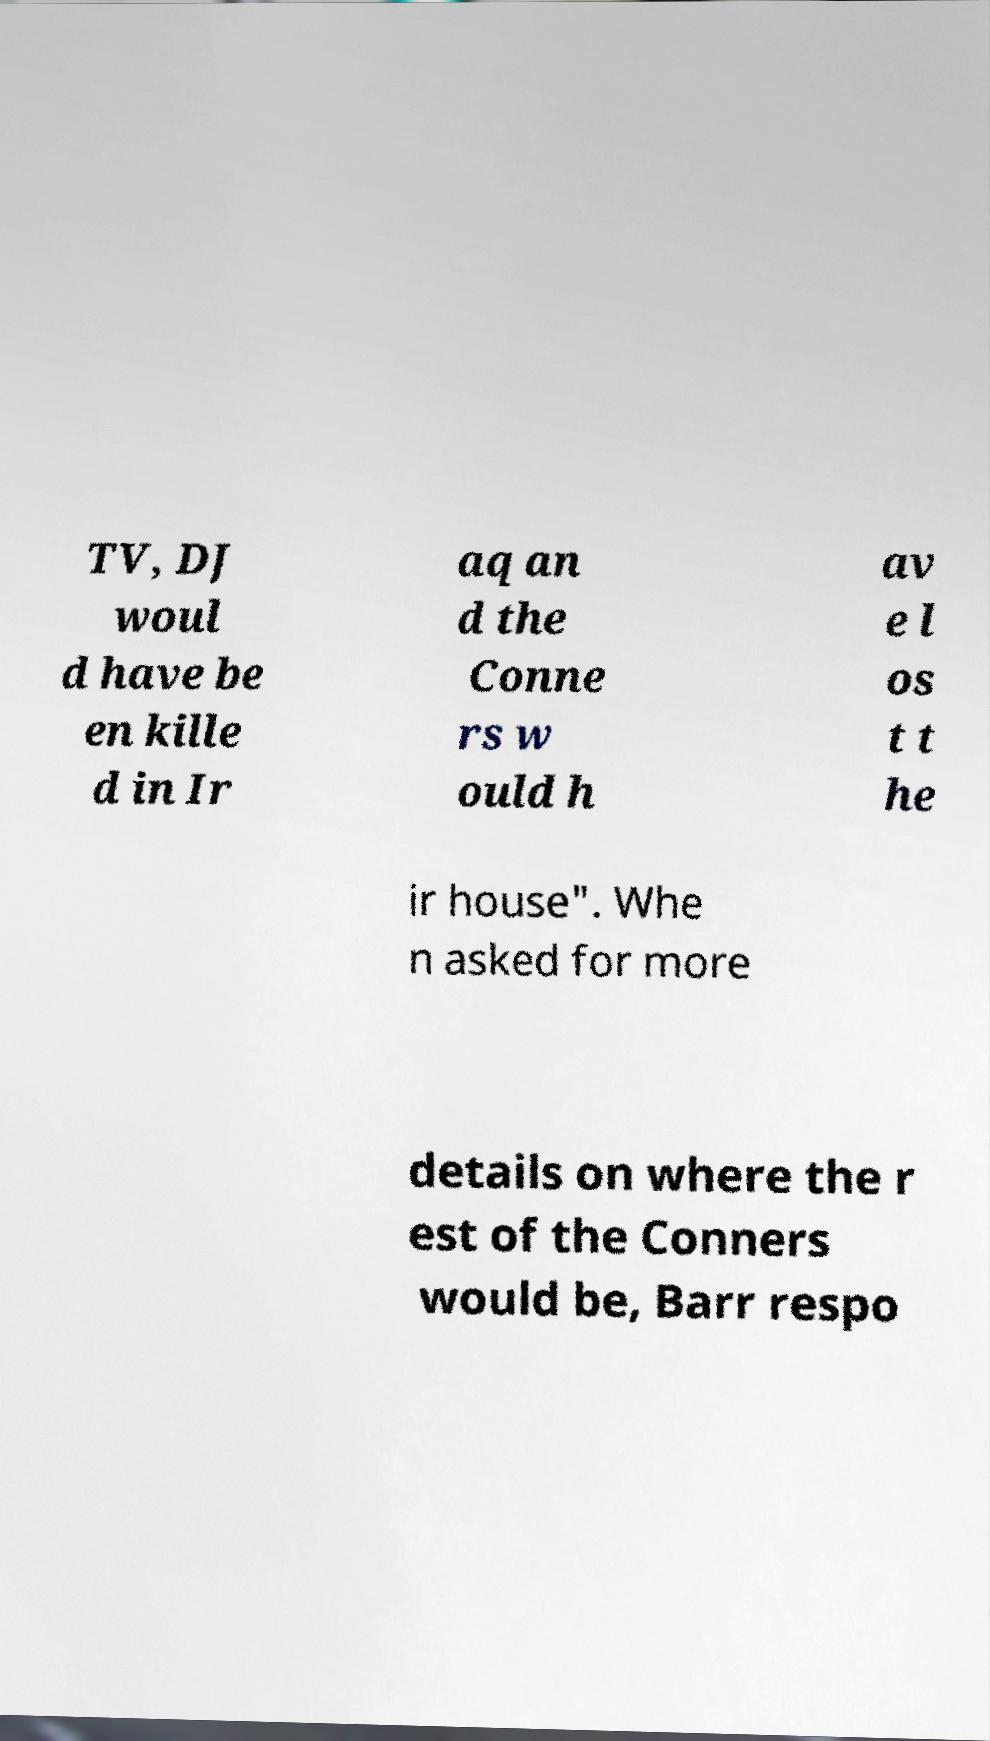Please read and relay the text visible in this image. What does it say? TV, DJ woul d have be en kille d in Ir aq an d the Conne rs w ould h av e l os t t he ir house". Whe n asked for more details on where the r est of the Conners would be, Barr respo 